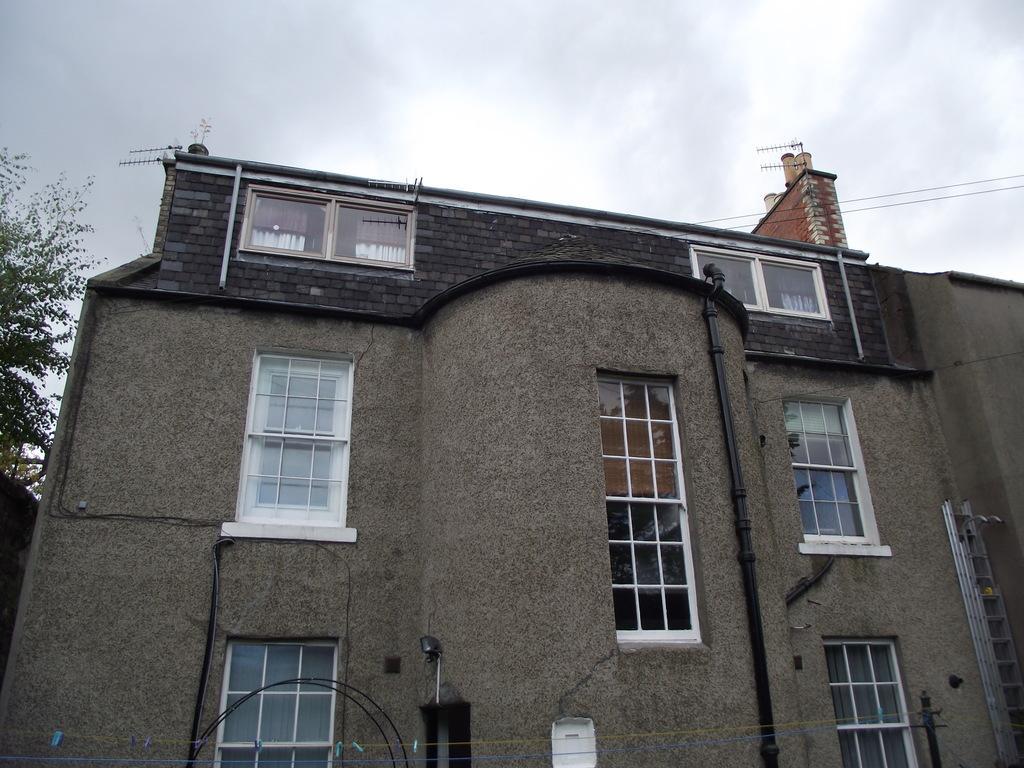Could you give a brief overview of what you see in this image? In this image there is a building. On the left we can see a tree. At the bottom there is a pole and we can see wires. In the background there is sky. 